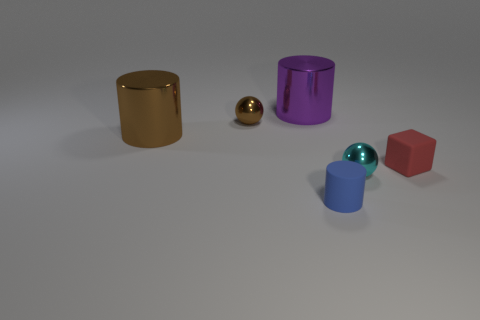Add 3 large purple objects. How many objects exist? 9 Subtract all balls. How many objects are left? 4 Add 1 tiny red objects. How many tiny red objects exist? 2 Subtract 0 purple balls. How many objects are left? 6 Subtract all brown metal things. Subtract all tiny brown spheres. How many objects are left? 3 Add 2 brown balls. How many brown balls are left? 3 